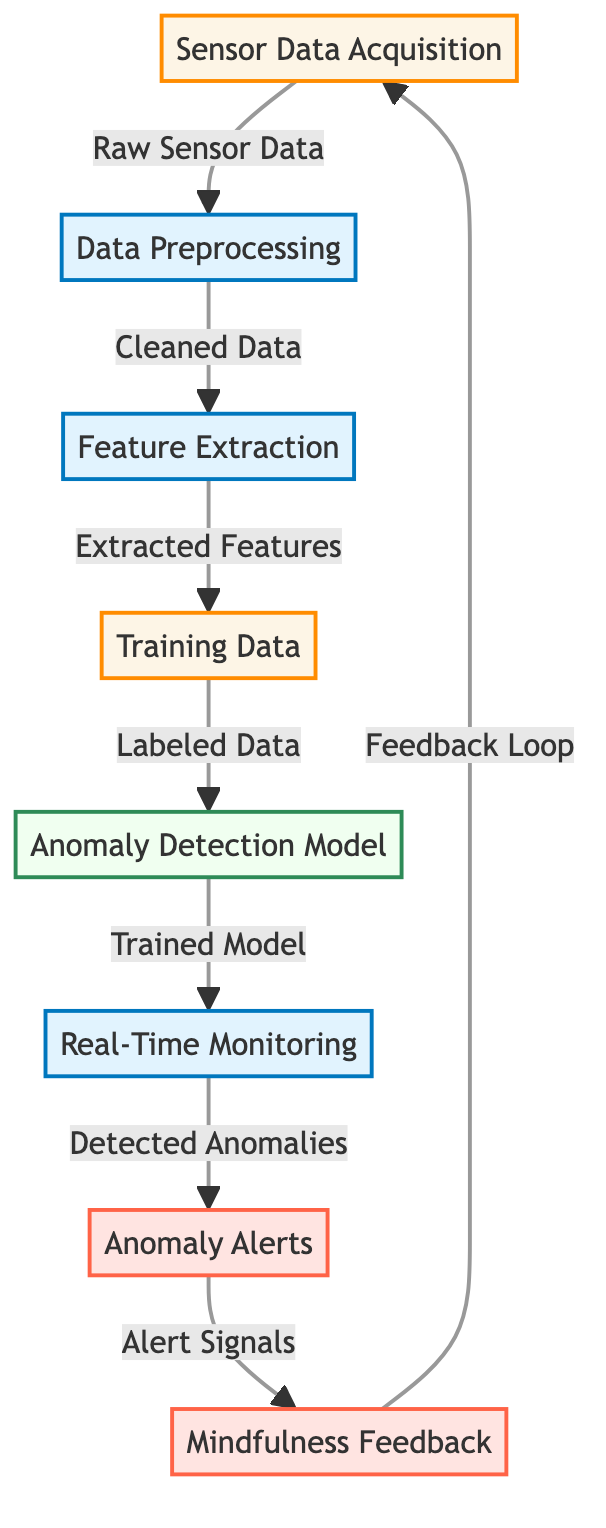1. What is the first step in the diagram? The first step in the diagram is "Sensor Data Acquisition," which represents the initial collection of raw data from sensors.
Answer: Sensor Data Acquisition 2. How many output nodes are present in the diagram? The diagram includes two output nodes: "Anomaly Alerts" and "Mindfulness Feedback."
Answer: 2 3. Which process node follows "Data Preprocessing"? The process node that follows "Data Preprocessing" is "Feature Extraction," indicating the next stage where features are derived from the cleaned data.
Answer: Feature Extraction 4. What type of model is used for detection? The diagram indicates that "Anomaly Detection Model" is used for detecting anomalies, as denoted by the model node classified in green.
Answer: Anomaly Detection Model 5. What signals are generated from detected anomalies? The "Anomaly Alerts" node represents the signals generated from detected anomalies, indicating the alerts triggered by the system.
Answer: Alert Signals 6. What leads to the "Mindfulness Feedback"? The "Anomaly Alerts" leads to "Mindfulness Feedback," establishing a connection where alerts generate feedback for users to improve their mindfulness practices.
Answer: Anomaly Alerts 7. What is the role of "Real-Time Monitoring"? "Real-Time Monitoring" is responsible for the process of observing incoming data continuously to identify any anomalies as they occur.
Answer: Observing data 8. How is the "Training Data" labeled? The "Training Data" is labeled as derived data that has been prepared for training the anomaly detection model after feature extraction.
Answer: Labeled Data 9. What is the final step in the diagram? The final step is the feedback loop that indicates the continuous improvement of the system, ultimately connecting back to sensor data acquisition.
Answer: Feedback Loop 10. What is the primary function of "Feature Extraction"? The primary function of "Feature Extraction" is to derive specific features from the cleaned data to facilitate model training for anomaly detection.
Answer: Derive features 